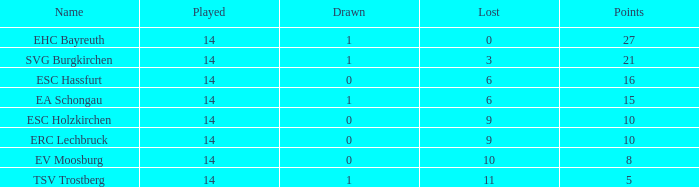Give me the full table as a dictionary. {'header': ['Name', 'Played', 'Drawn', 'Lost', 'Points'], 'rows': [['EHC Bayreuth', '14', '1', '0', '27'], ['SVG Burgkirchen', '14', '1', '3', '21'], ['ESC Hassfurt', '14', '0', '6', '16'], ['EA Schongau', '14', '1', '6', '15'], ['ESC Holzkirchen', '14', '0', '9', '10'], ['ERC Lechbruck', '14', '0', '9', '10'], ['EV Moosburg', '14', '0', '10', '8'], ['TSV Trostberg', '14', '1', '11', '5']]} What's the points that has a lost more 6, played less than 14 and a position more than 1? None. 